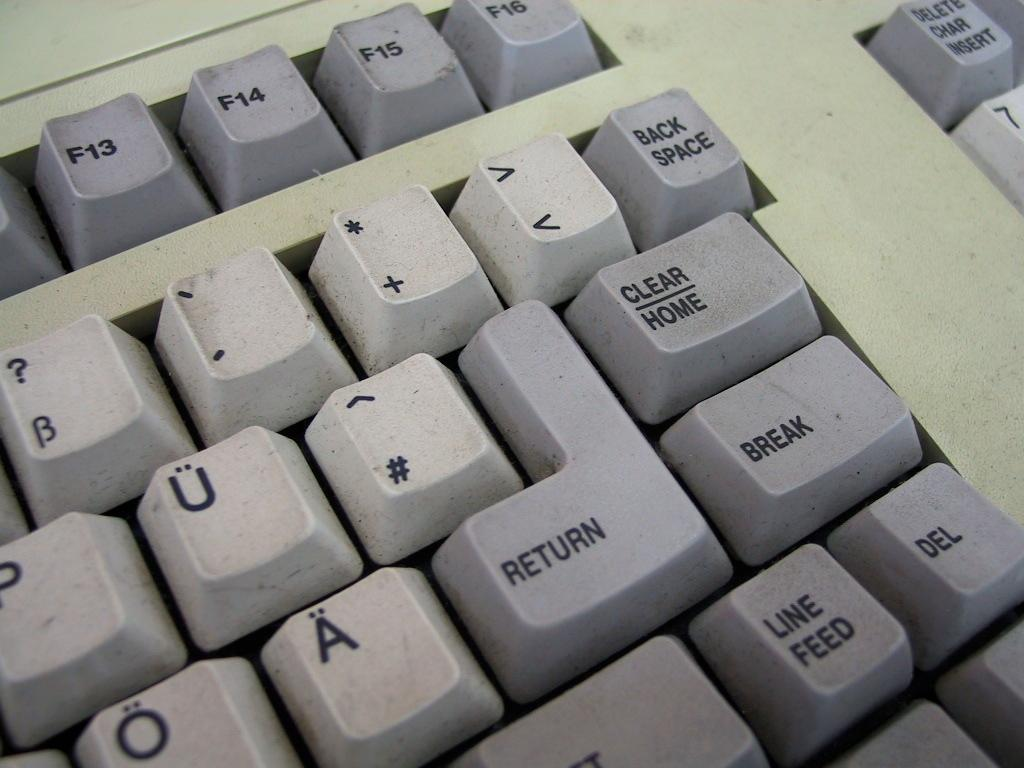<image>
Create a compact narrative representing the image presented. The right side of a keyboard, and the delete button is next to the line feed button. 